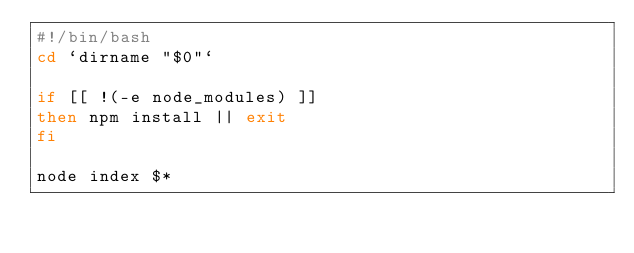Convert code to text. <code><loc_0><loc_0><loc_500><loc_500><_Bash_>#!/bin/bash
cd `dirname "$0"`

if [[ !(-e node_modules) ]]
then npm install || exit
fi

node index $*
</code> 